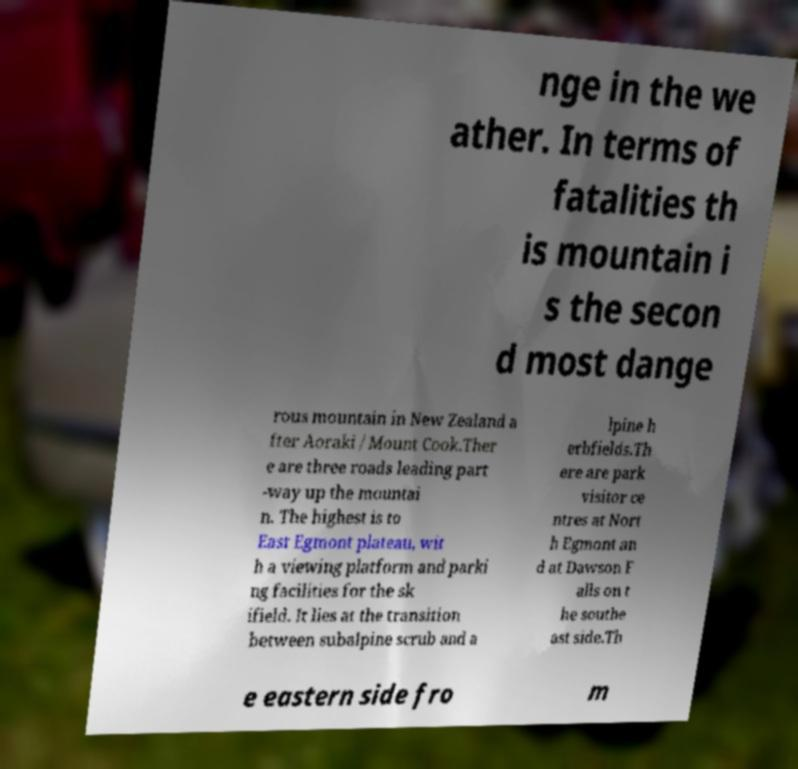For documentation purposes, I need the text within this image transcribed. Could you provide that? nge in the we ather. In terms of fatalities th is mountain i s the secon d most dange rous mountain in New Zealand a fter Aoraki / Mount Cook.Ther e are three roads leading part -way up the mountai n. The highest is to East Egmont plateau, wit h a viewing platform and parki ng facilities for the sk ifield. It lies at the transition between subalpine scrub and a lpine h erbfields.Th ere are park visitor ce ntres at Nort h Egmont an d at Dawson F alls on t he southe ast side.Th e eastern side fro m 